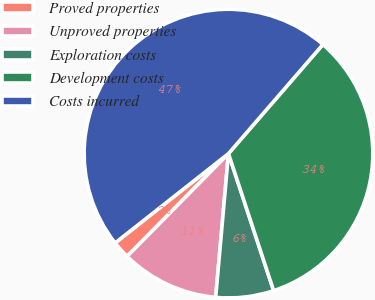<chart> <loc_0><loc_0><loc_500><loc_500><pie_chart><fcel>Proved properties<fcel>Unproved properties<fcel>Exploration costs<fcel>Development costs<fcel>Costs incurred<nl><fcel>1.98%<fcel>10.98%<fcel>6.48%<fcel>33.58%<fcel>46.98%<nl></chart> 